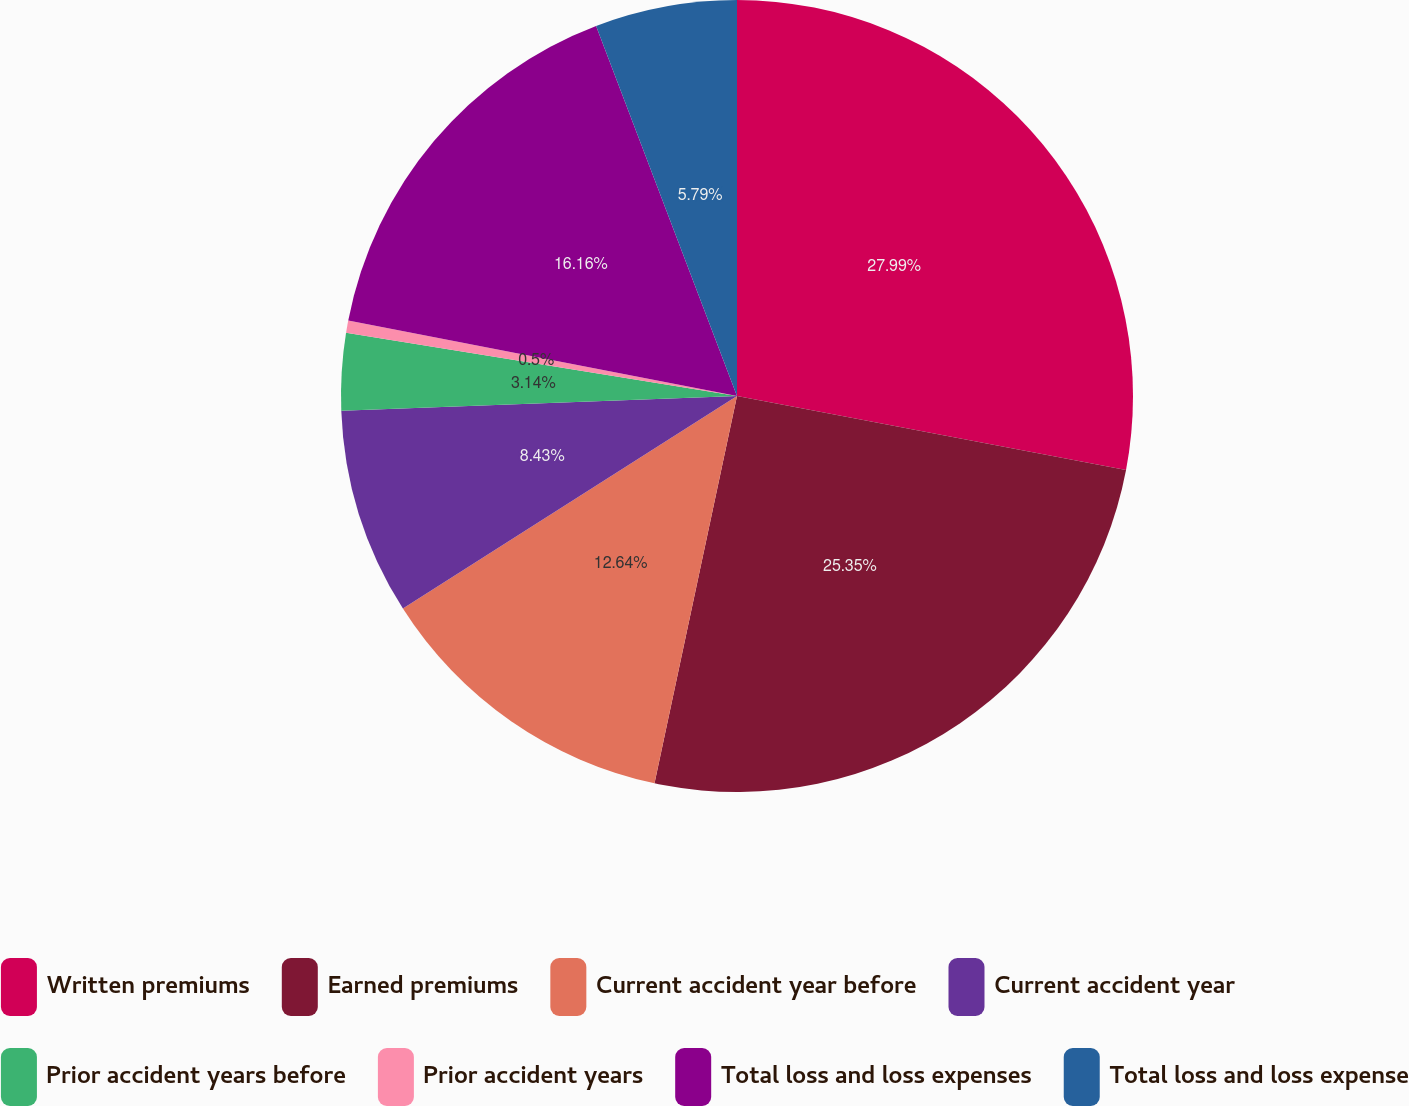Convert chart. <chart><loc_0><loc_0><loc_500><loc_500><pie_chart><fcel>Written premiums<fcel>Earned premiums<fcel>Current accident year before<fcel>Current accident year<fcel>Prior accident years before<fcel>Prior accident years<fcel>Total loss and loss expenses<fcel>Total loss and loss expense<nl><fcel>27.99%<fcel>25.35%<fcel>12.64%<fcel>8.43%<fcel>3.14%<fcel>0.5%<fcel>16.16%<fcel>5.79%<nl></chart> 